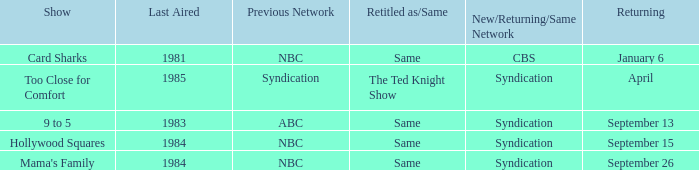What was the earliest aired show that's returning on September 13? 1983.0. 